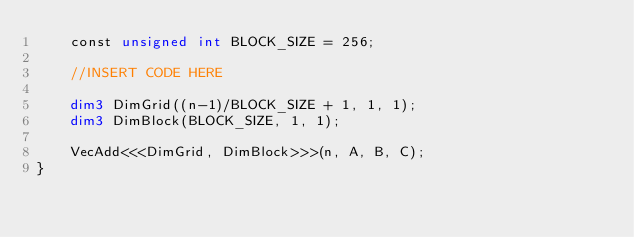<code> <loc_0><loc_0><loc_500><loc_500><_Cuda_>    const unsigned int BLOCK_SIZE = 256;

    //INSERT CODE HERE
    
    dim3 DimGrid((n-1)/BLOCK_SIZE + 1, 1, 1);
    dim3 DimBlock(BLOCK_SIZE, 1, 1);
    
    VecAdd<<<DimGrid, DimBlock>>>(n, A, B, C);
}

</code> 